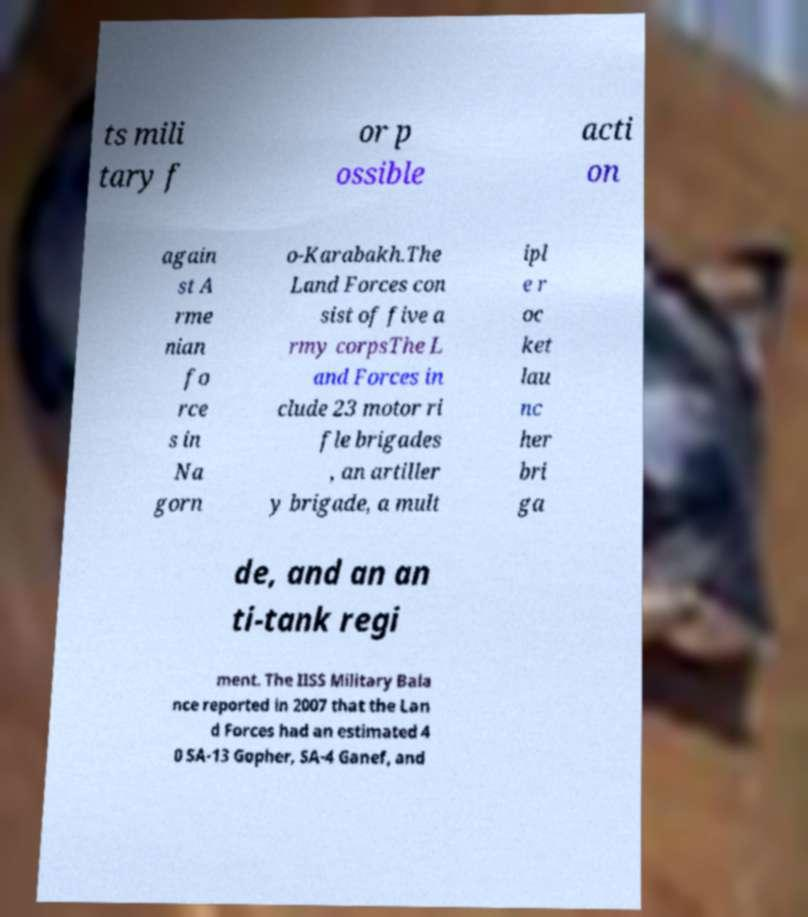There's text embedded in this image that I need extracted. Can you transcribe it verbatim? ts mili tary f or p ossible acti on again st A rme nian fo rce s in Na gorn o-Karabakh.The Land Forces con sist of five a rmy corpsThe L and Forces in clude 23 motor ri fle brigades , an artiller y brigade, a mult ipl e r oc ket lau nc her bri ga de, and an an ti-tank regi ment. The IISS Military Bala nce reported in 2007 that the Lan d Forces had an estimated 4 0 SA-13 Gopher, SA-4 Ganef, and 